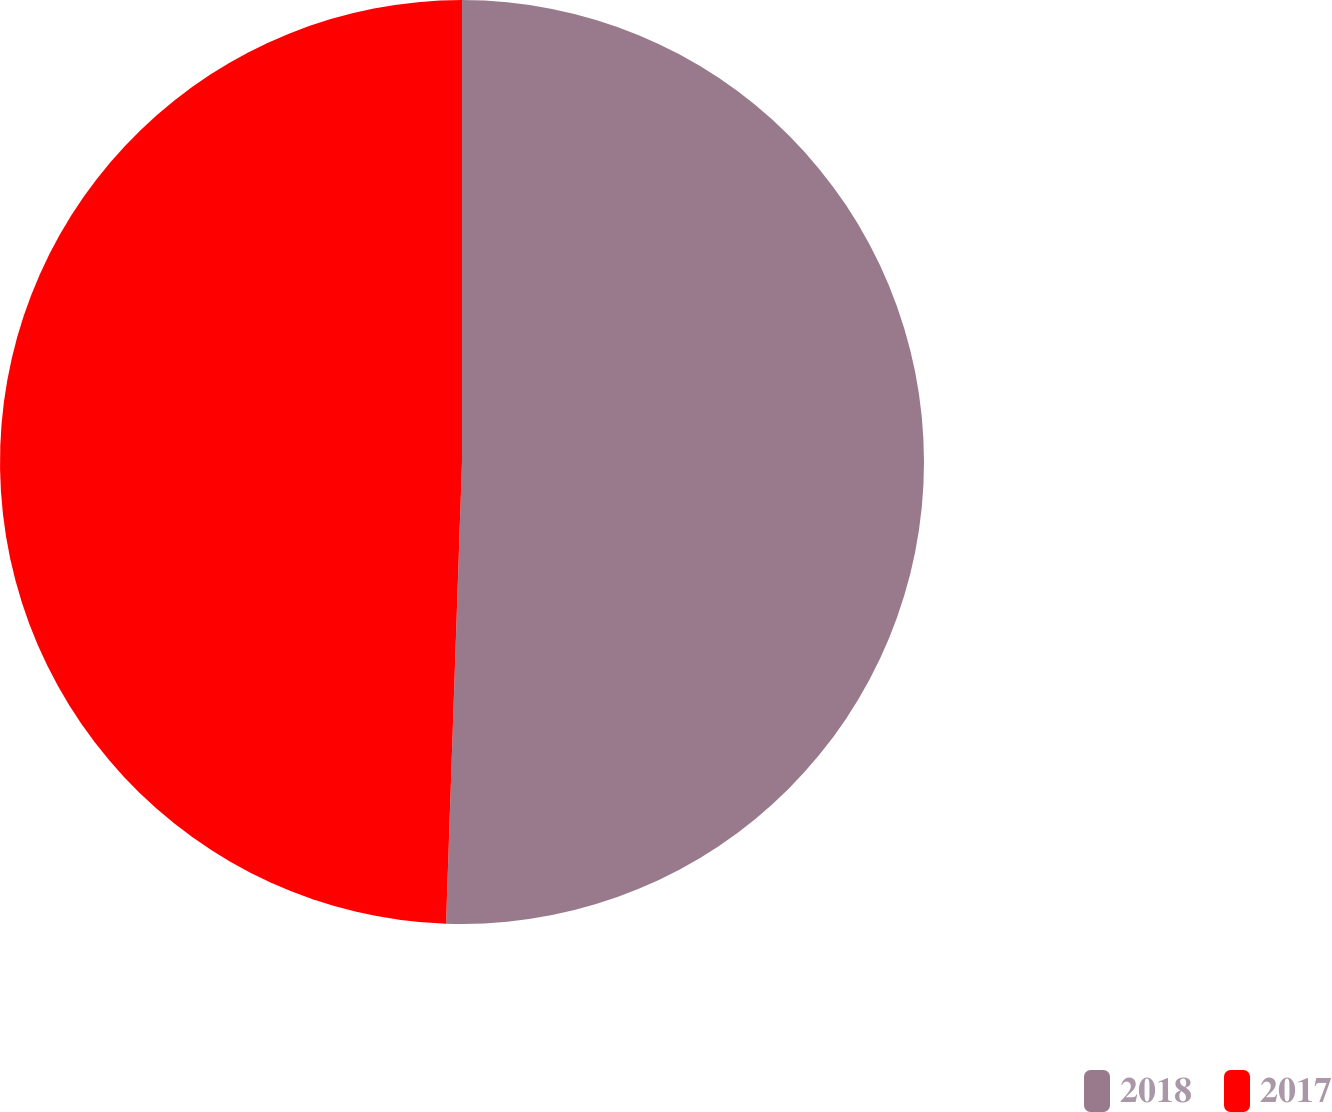<chart> <loc_0><loc_0><loc_500><loc_500><pie_chart><fcel>2018<fcel>2017<nl><fcel>50.55%<fcel>49.45%<nl></chart> 